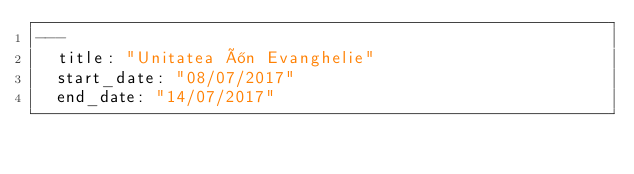<code> <loc_0><loc_0><loc_500><loc_500><_YAML_>---
  title: "Unitatea în Evanghelie"
  start_date: "08/07/2017"
  end_date: "14/07/2017"</code> 